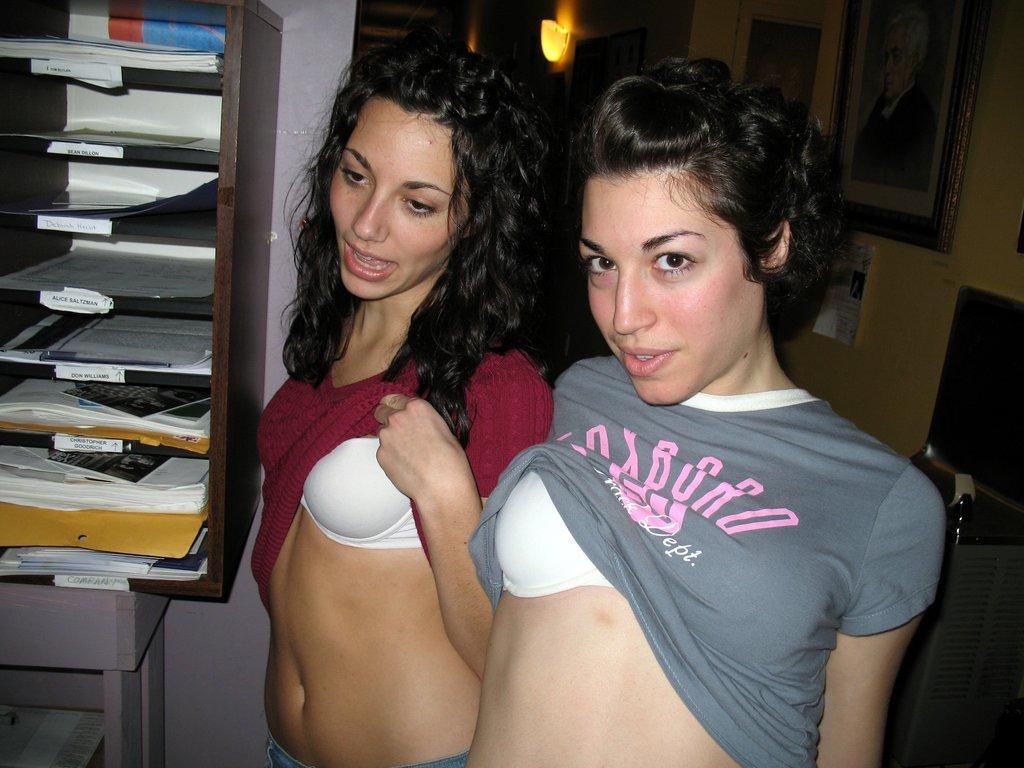<image>
Give a short and clear explanation of the subsequent image. Two ladies pulling up the shirts in an office with one shirt daying Track dept. 